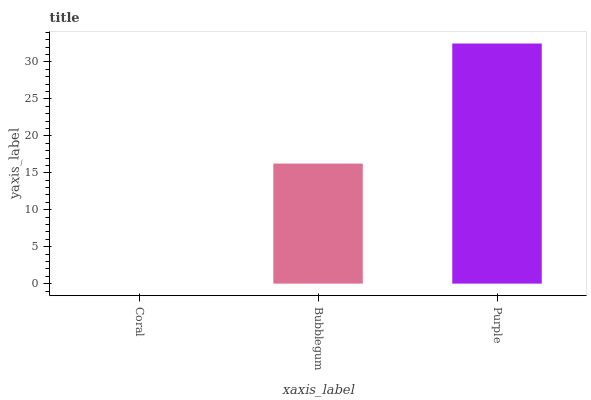Is Bubblegum the minimum?
Answer yes or no. No. Is Bubblegum the maximum?
Answer yes or no. No. Is Bubblegum greater than Coral?
Answer yes or no. Yes. Is Coral less than Bubblegum?
Answer yes or no. Yes. Is Coral greater than Bubblegum?
Answer yes or no. No. Is Bubblegum less than Coral?
Answer yes or no. No. Is Bubblegum the high median?
Answer yes or no. Yes. Is Bubblegum the low median?
Answer yes or no. Yes. Is Coral the high median?
Answer yes or no. No. Is Purple the low median?
Answer yes or no. No. 